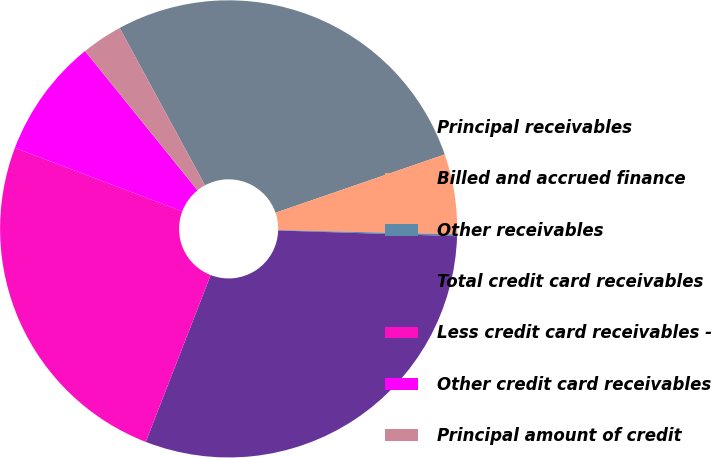Convert chart. <chart><loc_0><loc_0><loc_500><loc_500><pie_chart><fcel>Principal receivables<fcel>Billed and accrued finance<fcel>Other receivables<fcel>Total credit card receivables<fcel>Less credit card receivables -<fcel>Other credit card receivables<fcel>Principal amount of credit<nl><fcel>27.63%<fcel>5.66%<fcel>0.13%<fcel>30.39%<fcel>24.86%<fcel>8.42%<fcel>2.9%<nl></chart> 